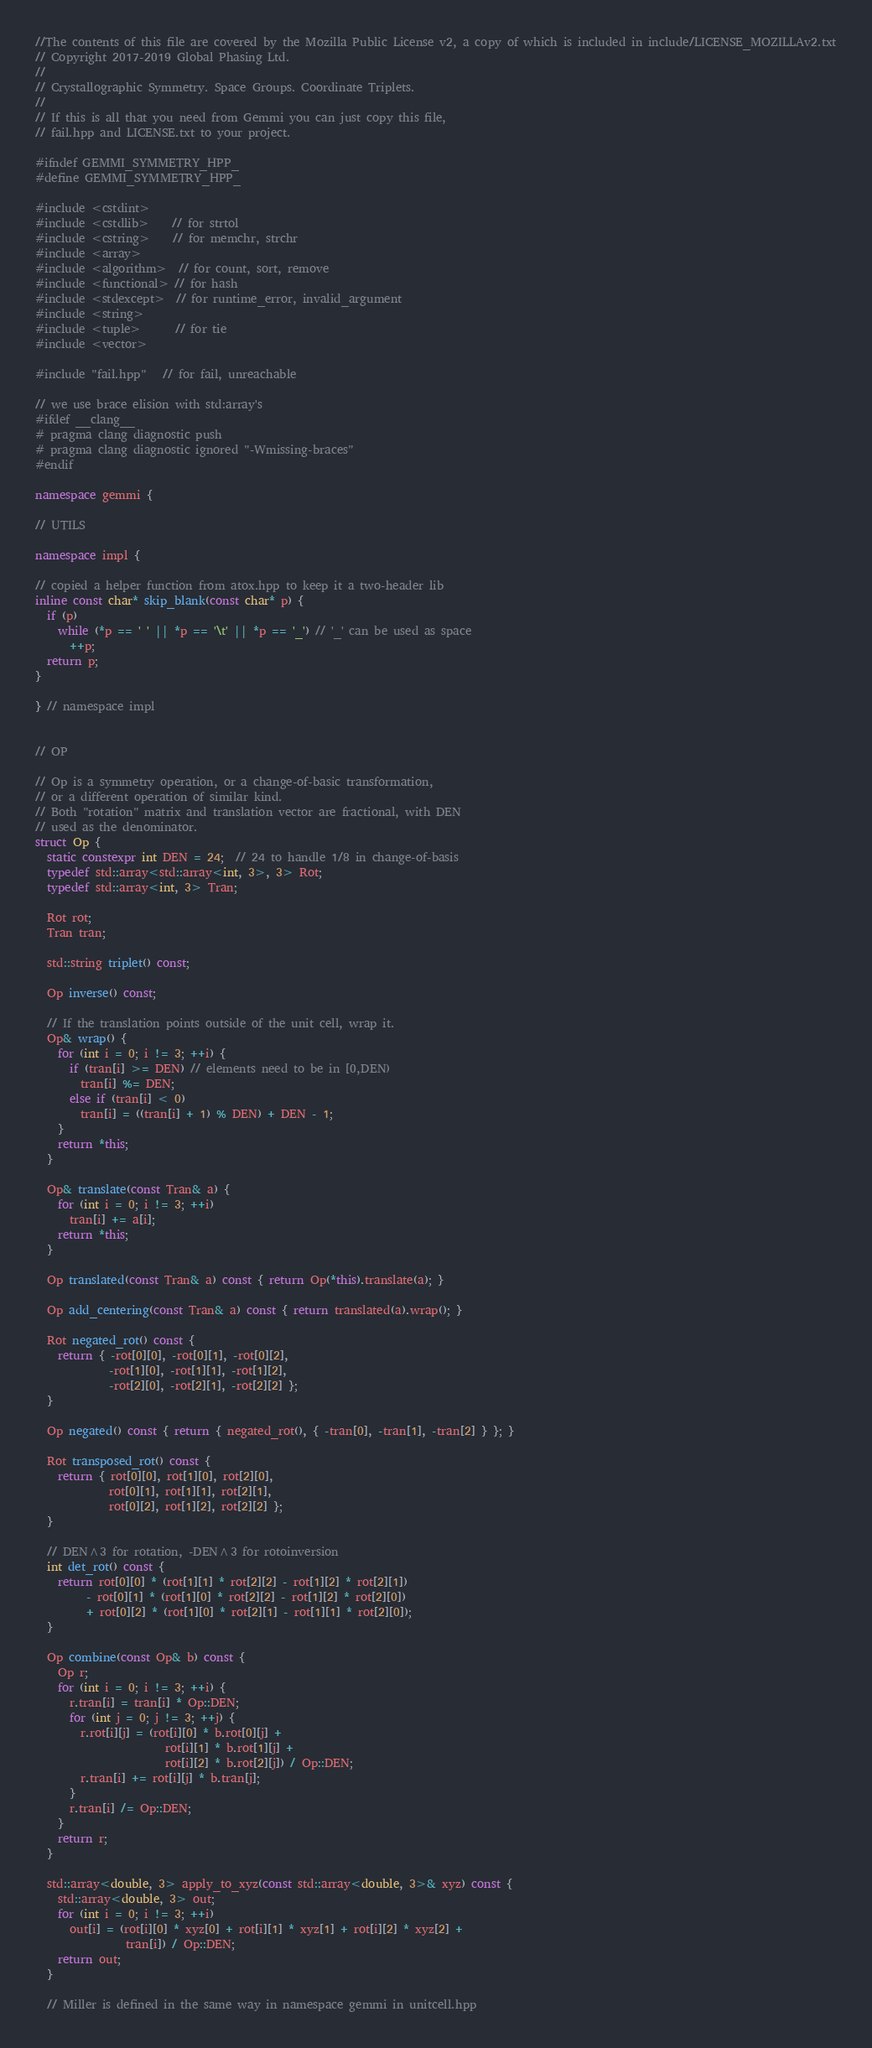Convert code to text. <code><loc_0><loc_0><loc_500><loc_500><_C++_>//The contents of this file are covered by the Mozilla Public License v2, a copy of which is included in include/LICENSE_MOZILLAv2.txt
// Copyright 2017-2019 Global Phasing Ltd.
//
// Crystallographic Symmetry. Space Groups. Coordinate Triplets.
//
// If this is all that you need from Gemmi you can just copy this file,
// fail.hpp and LICENSE.txt to your project.

#ifndef GEMMI_SYMMETRY_HPP_
#define GEMMI_SYMMETRY_HPP_

#include <cstdint>
#include <cstdlib>    // for strtol
#include <cstring>    // for memchr, strchr
#include <array>
#include <algorithm>  // for count, sort, remove
#include <functional> // for hash
#include <stdexcept>  // for runtime_error, invalid_argument
#include <string>
#include <tuple>      // for tie
#include <vector>

#include "fail.hpp"   // for fail, unreachable

// we use brace elision with std:array's
#ifdef __clang__
# pragma clang diagnostic push
# pragma clang diagnostic ignored "-Wmissing-braces"
#endif

namespace gemmi {

// UTILS

namespace impl {

// copied a helper function from atox.hpp to keep it a two-header lib
inline const char* skip_blank(const char* p) {
  if (p)
    while (*p == ' ' || *p == '\t' || *p == '_') // '_' can be used as space
      ++p;
  return p;
}

} // namespace impl


// OP

// Op is a symmetry operation, or a change-of-basic transformation,
// or a different operation of similar kind.
// Both "rotation" matrix and translation vector are fractional, with DEN
// used as the denominator.
struct Op {
  static constexpr int DEN = 24;  // 24 to handle 1/8 in change-of-basis
  typedef std::array<std::array<int, 3>, 3> Rot;
  typedef std::array<int, 3> Tran;

  Rot rot;
  Tran tran;

  std::string triplet() const;

  Op inverse() const;

  // If the translation points outside of the unit cell, wrap it.
  Op& wrap() {
    for (int i = 0; i != 3; ++i) {
      if (tran[i] >= DEN) // elements need to be in [0,DEN)
        tran[i] %= DEN;
      else if (tran[i] < 0)
        tran[i] = ((tran[i] + 1) % DEN) + DEN - 1;
    }
    return *this;
  }

  Op& translate(const Tran& a) {
    for (int i = 0; i != 3; ++i)
      tran[i] += a[i];
    return *this;
  }

  Op translated(const Tran& a) const { return Op(*this).translate(a); }

  Op add_centering(const Tran& a) const { return translated(a).wrap(); }

  Rot negated_rot() const {
    return { -rot[0][0], -rot[0][1], -rot[0][2],
             -rot[1][0], -rot[1][1], -rot[1][2],
             -rot[2][0], -rot[2][1], -rot[2][2] };
  }

  Op negated() const { return { negated_rot(), { -tran[0], -tran[1], -tran[2] } }; }

  Rot transposed_rot() const {
    return { rot[0][0], rot[1][0], rot[2][0],
             rot[0][1], rot[1][1], rot[2][1],
             rot[0][2], rot[1][2], rot[2][2] };
  }

  // DEN^3 for rotation, -DEN^3 for rotoinversion
  int det_rot() const {
    return rot[0][0] * (rot[1][1] * rot[2][2] - rot[1][2] * rot[2][1])
         - rot[0][1] * (rot[1][0] * rot[2][2] - rot[1][2] * rot[2][0])
         + rot[0][2] * (rot[1][0] * rot[2][1] - rot[1][1] * rot[2][0]);
  }

  Op combine(const Op& b) const {
    Op r;
    for (int i = 0; i != 3; ++i) {
      r.tran[i] = tran[i] * Op::DEN;
      for (int j = 0; j != 3; ++j) {
        r.rot[i][j] = (rot[i][0] * b.rot[0][j] +
                       rot[i][1] * b.rot[1][j] +
                       rot[i][2] * b.rot[2][j]) / Op::DEN;
        r.tran[i] += rot[i][j] * b.tran[j];
      }
      r.tran[i] /= Op::DEN;
    }
    return r;
  }

  std::array<double, 3> apply_to_xyz(const std::array<double, 3>& xyz) const {
    std::array<double, 3> out;
    for (int i = 0; i != 3; ++i)
      out[i] = (rot[i][0] * xyz[0] + rot[i][1] * xyz[1] + rot[i][2] * xyz[2] +
                tran[i]) / Op::DEN;
    return out;
  }

  // Miller is defined in the same way in namespace gemmi in unitcell.hpp</code> 